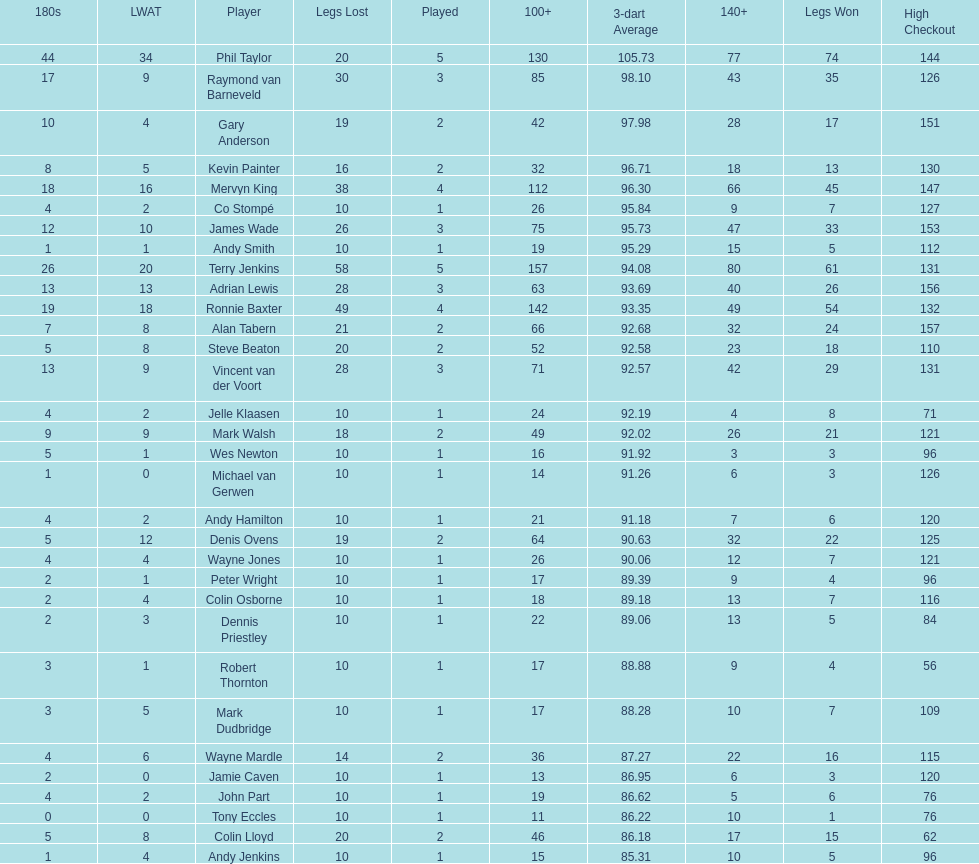Which player lost the least? Co Stompé, Andy Smith, Jelle Klaasen, Wes Newton, Michael van Gerwen, Andy Hamilton, Wayne Jones, Peter Wright, Colin Osborne, Dennis Priestley, Robert Thornton, Mark Dudbridge, Jamie Caven, John Part, Tony Eccles, Andy Jenkins. 